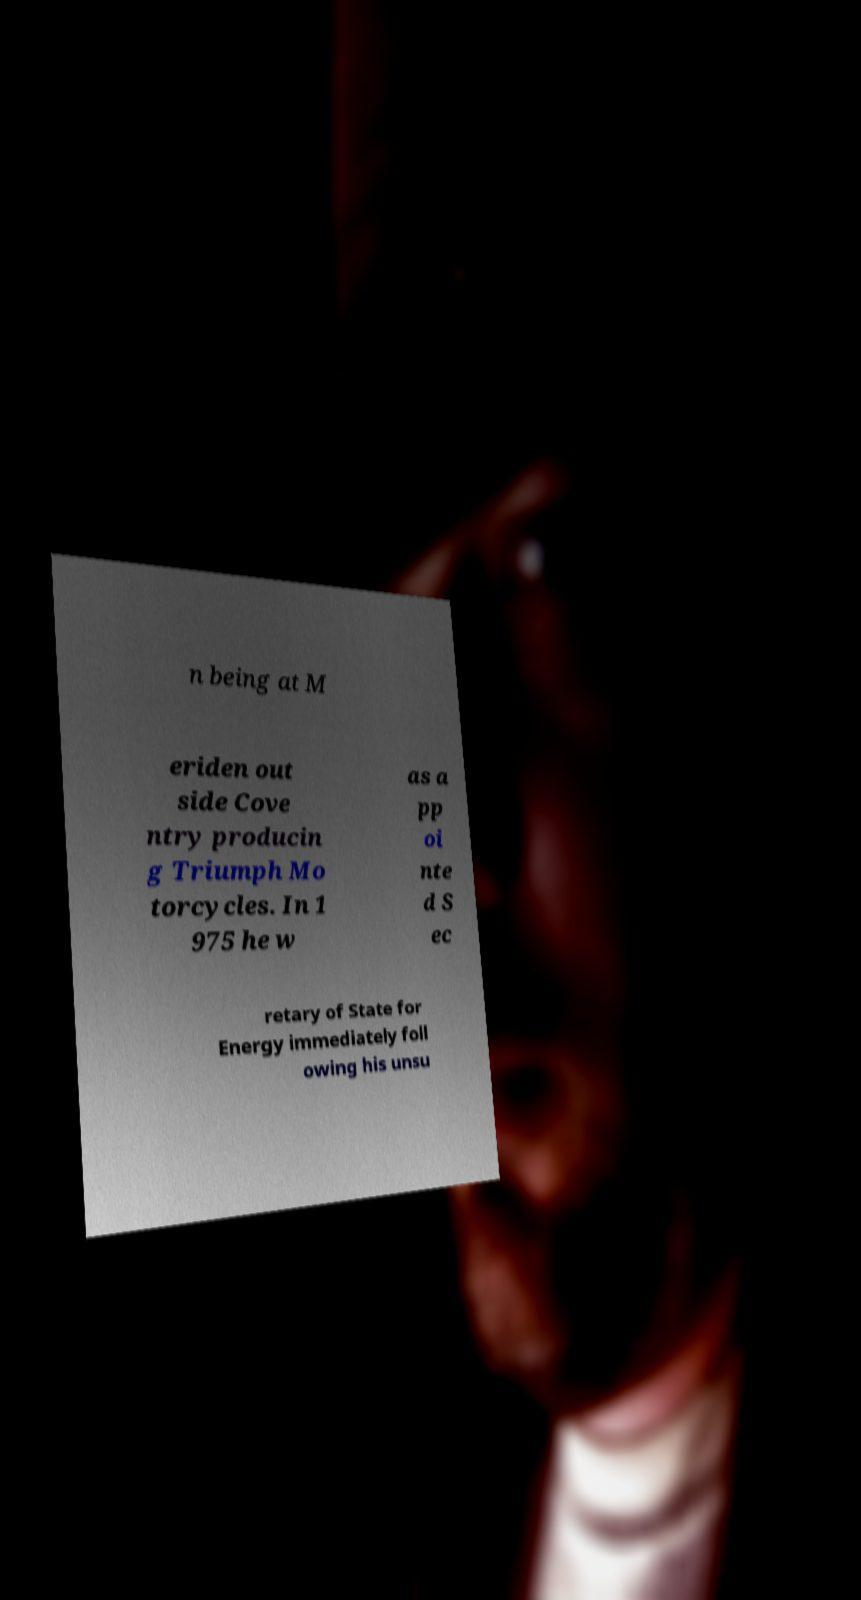For documentation purposes, I need the text within this image transcribed. Could you provide that? n being at M eriden out side Cove ntry producin g Triumph Mo torcycles. In 1 975 he w as a pp oi nte d S ec retary of State for Energy immediately foll owing his unsu 